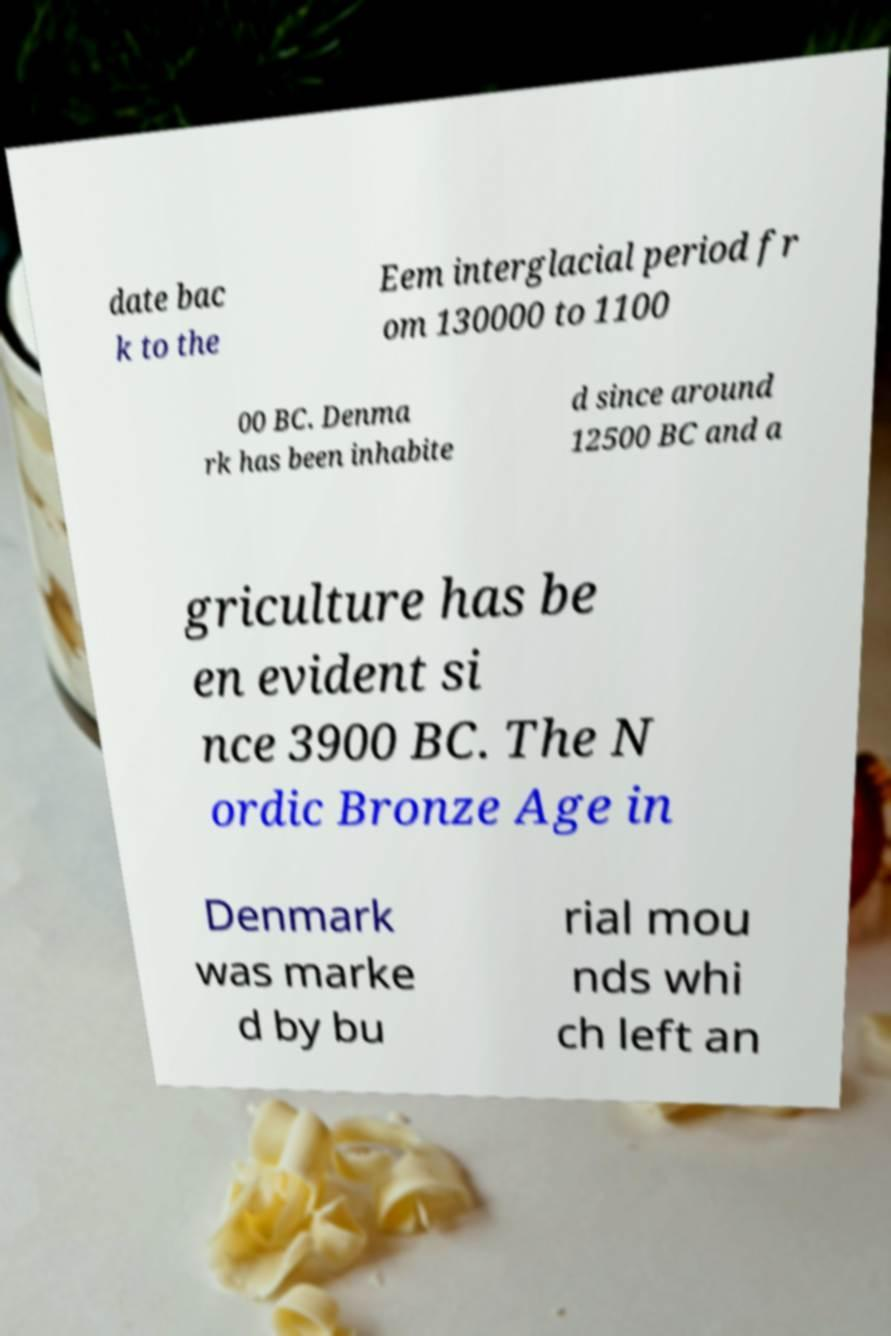There's text embedded in this image that I need extracted. Can you transcribe it verbatim? date bac k to the Eem interglacial period fr om 130000 to 1100 00 BC. Denma rk has been inhabite d since around 12500 BC and a griculture has be en evident si nce 3900 BC. The N ordic Bronze Age in Denmark was marke d by bu rial mou nds whi ch left an 